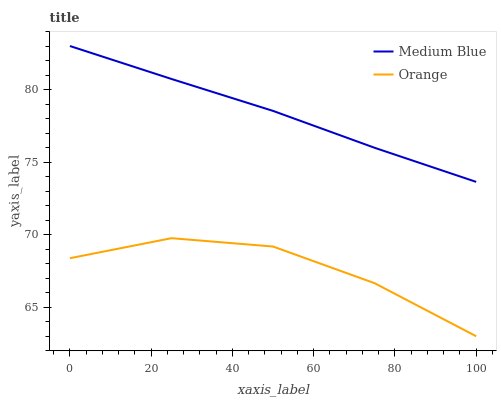Does Orange have the minimum area under the curve?
Answer yes or no. Yes. Does Medium Blue have the maximum area under the curve?
Answer yes or no. Yes. Does Medium Blue have the minimum area under the curve?
Answer yes or no. No. Is Medium Blue the smoothest?
Answer yes or no. Yes. Is Orange the roughest?
Answer yes or no. Yes. Is Medium Blue the roughest?
Answer yes or no. No. Does Orange have the lowest value?
Answer yes or no. Yes. Does Medium Blue have the lowest value?
Answer yes or no. No. Does Medium Blue have the highest value?
Answer yes or no. Yes. Is Orange less than Medium Blue?
Answer yes or no. Yes. Is Medium Blue greater than Orange?
Answer yes or no. Yes. Does Orange intersect Medium Blue?
Answer yes or no. No. 